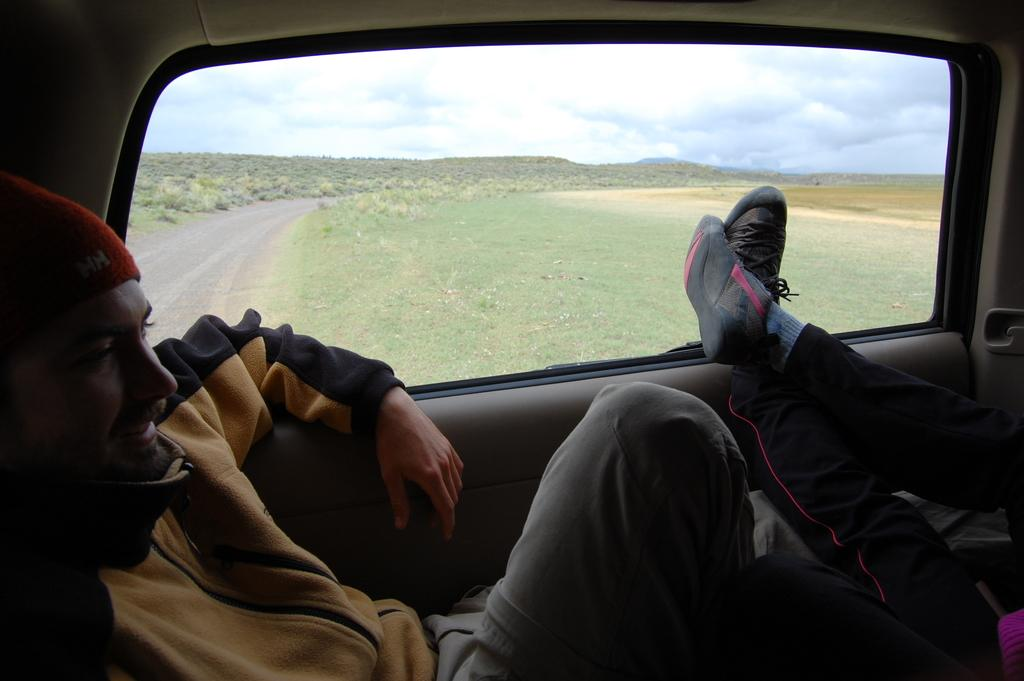How many people are inside the car in the image? There are two people sitting inside the car. What feature of the car is visible in the image? The car has a window. What can be seen through the window of the car? The road is visible through the window. What type of vegetation is present outside the car? Grass is present on the surface outside the car. What type of beast can be seen roaming around the car in the image? There is no beast present in the image; it only shows two people sitting inside a car with a window and grass outside. 